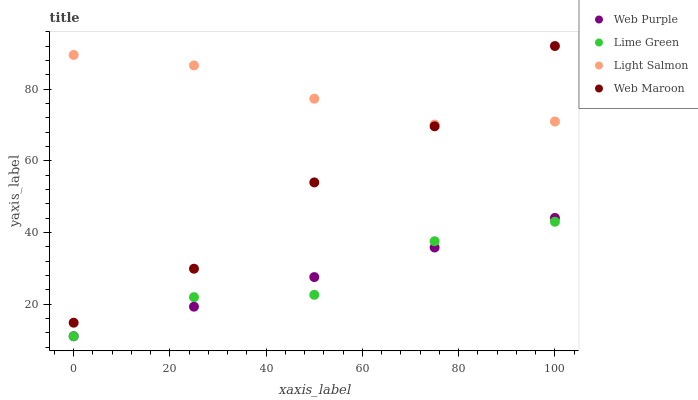Does Lime Green have the minimum area under the curve?
Answer yes or no. Yes. Does Light Salmon have the maximum area under the curve?
Answer yes or no. Yes. Does Web Purple have the minimum area under the curve?
Answer yes or no. No. Does Web Purple have the maximum area under the curve?
Answer yes or no. No. Is Web Purple the smoothest?
Answer yes or no. Yes. Is Lime Green the roughest?
Answer yes or no. Yes. Is Lime Green the smoothest?
Answer yes or no. No. Is Web Purple the roughest?
Answer yes or no. No. Does Web Purple have the lowest value?
Answer yes or no. Yes. Does Light Salmon have the lowest value?
Answer yes or no. No. Does Web Maroon have the highest value?
Answer yes or no. Yes. Does Web Purple have the highest value?
Answer yes or no. No. Is Web Purple less than Web Maroon?
Answer yes or no. Yes. Is Light Salmon greater than Web Purple?
Answer yes or no. Yes. Does Web Maroon intersect Light Salmon?
Answer yes or no. Yes. Is Web Maroon less than Light Salmon?
Answer yes or no. No. Is Web Maroon greater than Light Salmon?
Answer yes or no. No. Does Web Purple intersect Web Maroon?
Answer yes or no. No. 